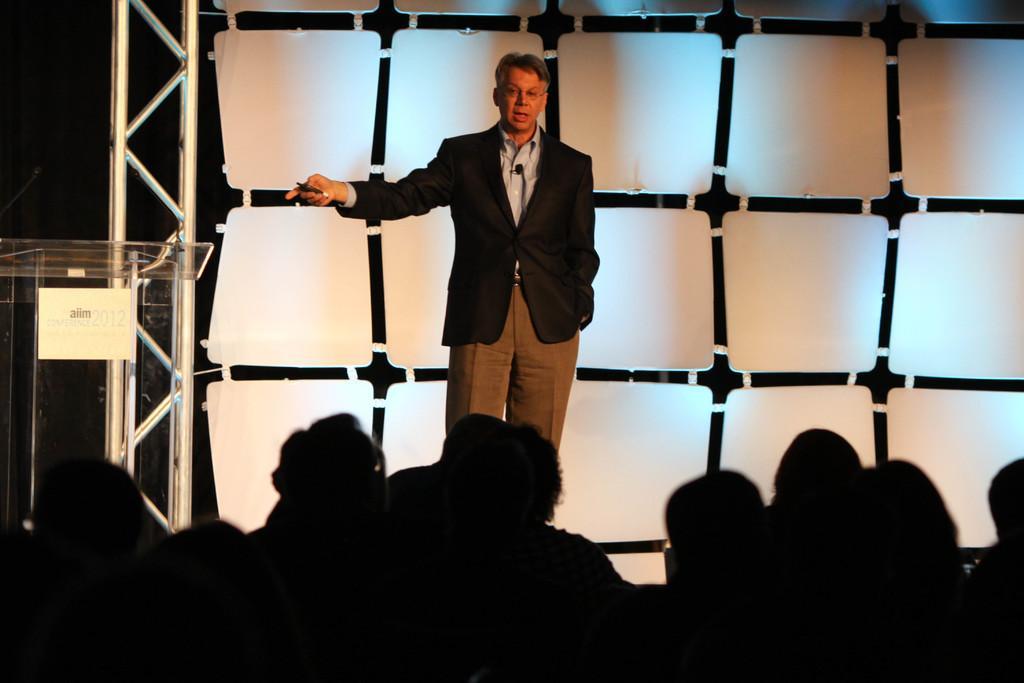How would you summarize this image in a sentence or two? At the bottom, I can see a crowd of people in the dark. They are facing towards the back side. In the background there is a man standing on the stage and speaking. He is holding an object in the hand. On the left side there is a glass podium. In the background there is a metal frame and white color objects. The background is dark. 